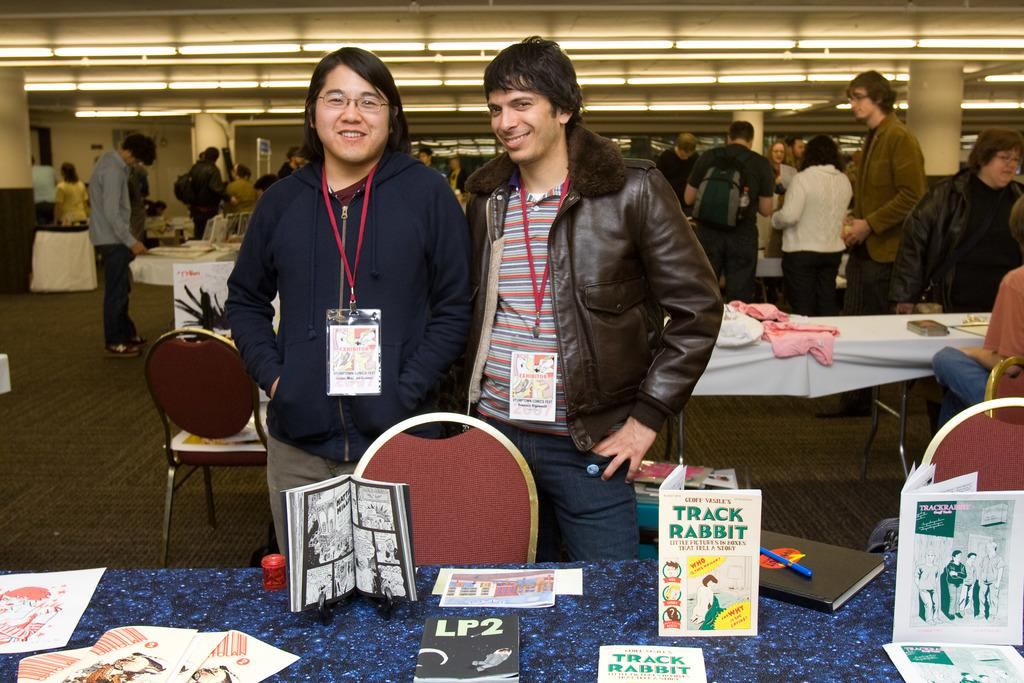<image>
Write a terse but informative summary of the picture. Two men standing in front of a table with some books on display like Track Rabbit. 